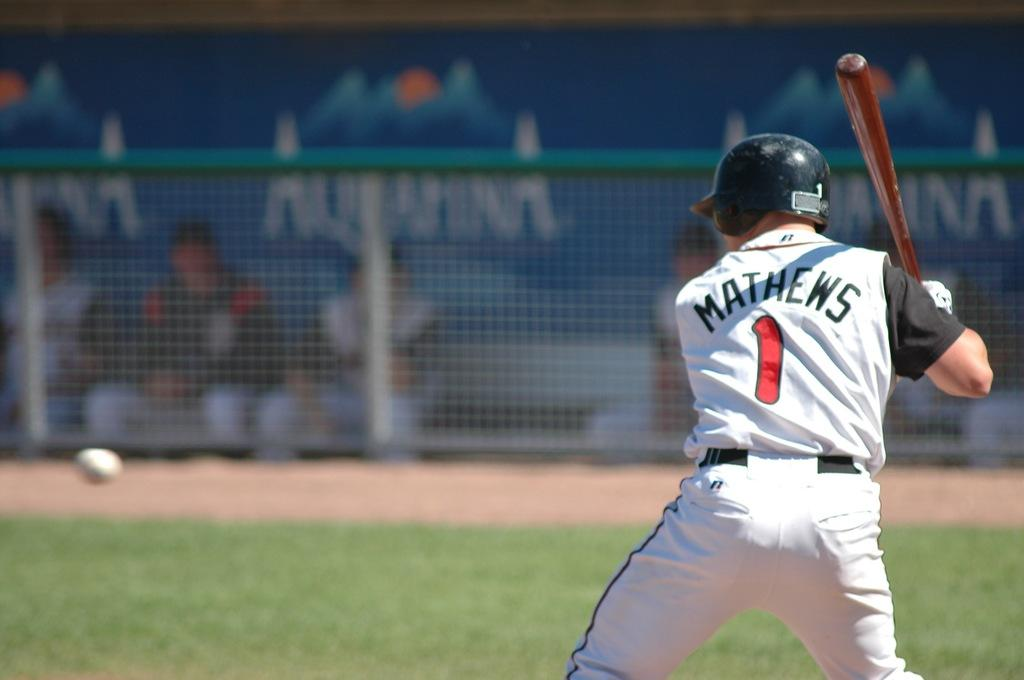Who or what is the main subject in the image? There is a person in the image. What is the person wearing? The person is wearing a helmet. What is the person holding? The person is holding a bat. What can be seen in the background of the image? There is fencing with mesh in the background. How would you describe the background's appearance? The background appears blurry. What type of industry can be seen in the background of the image? There is no industry visible in the background of the image; it features fencing with mesh. Is there a mailbox present in the image? No, there is no mailbox present in the image. 